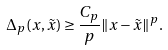Convert formula to latex. <formula><loc_0><loc_0><loc_500><loc_500>\Delta _ { p } ( x , \tilde { x } ) \geq \frac { C _ { p } } { p } \| x - \tilde { x } \| ^ { p } .</formula> 